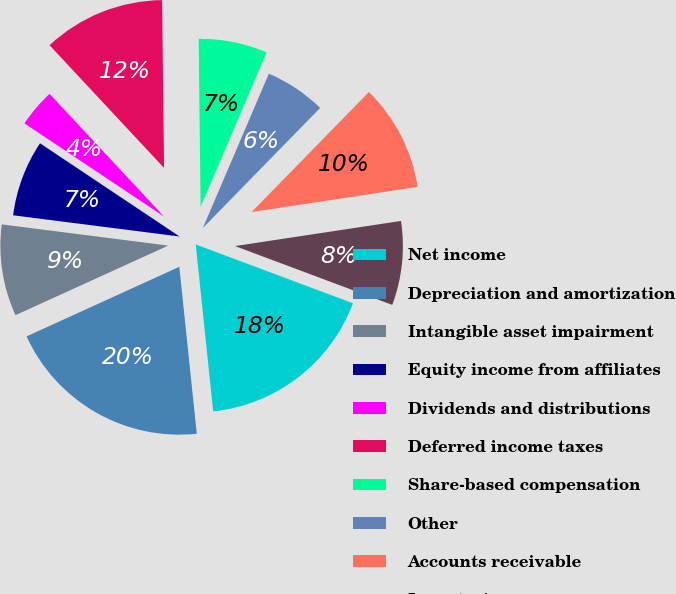Convert chart to OTSL. <chart><loc_0><loc_0><loc_500><loc_500><pie_chart><fcel>Net income<fcel>Depreciation and amortization<fcel>Intangible asset impairment<fcel>Equity income from affiliates<fcel>Dividends and distributions<fcel>Deferred income taxes<fcel>Share-based compensation<fcel>Other<fcel>Accounts receivable<fcel>Inventories<nl><fcel>17.64%<fcel>19.85%<fcel>8.82%<fcel>7.35%<fcel>3.68%<fcel>11.76%<fcel>6.62%<fcel>5.88%<fcel>10.29%<fcel>8.09%<nl></chart> 